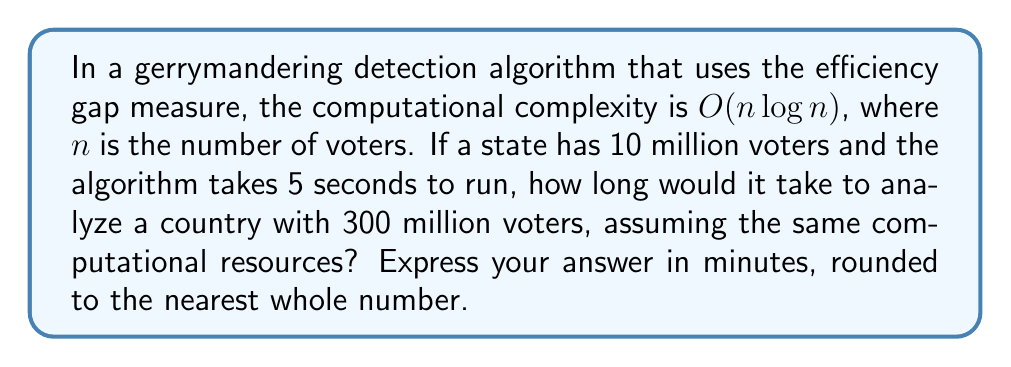Could you help me with this problem? To solve this problem, we need to follow these steps:

1) First, let's establish the relationship between the input size and time complexity:

   $T(n) = k \cdot n \log n$, where $k$ is a constant

2) We know that for 10 million voters (10,000,000), it takes 5 seconds:

   $5 = k \cdot 10,000,000 \log 10,000,000$

3) We can solve for $k$:

   $k = \frac{5}{10,000,000 \log 10,000,000} \approx 2.17 \times 10^{-8}$

4) Now, for 300 million voters (300,000,000), the time will be:

   $T(300,000,000) = 2.17 \times 10^{-8} \cdot 300,000,000 \log 300,000,000$

5) Calculating this:

   $T(300,000,000) \approx 195.3$ seconds

6) Converting to minutes:

   $195.3 \text{ seconds} \approx 3.255 \text{ minutes}$

7) Rounding to the nearest whole number:

   $3.255 \text{ minutes} \approx 3 \text{ minutes}$

This analysis demonstrates how the efficiency of algorithms becomes crucial when dealing with large-scale data, such as national voter information in gerrymandering detection.
Answer: 3 minutes 